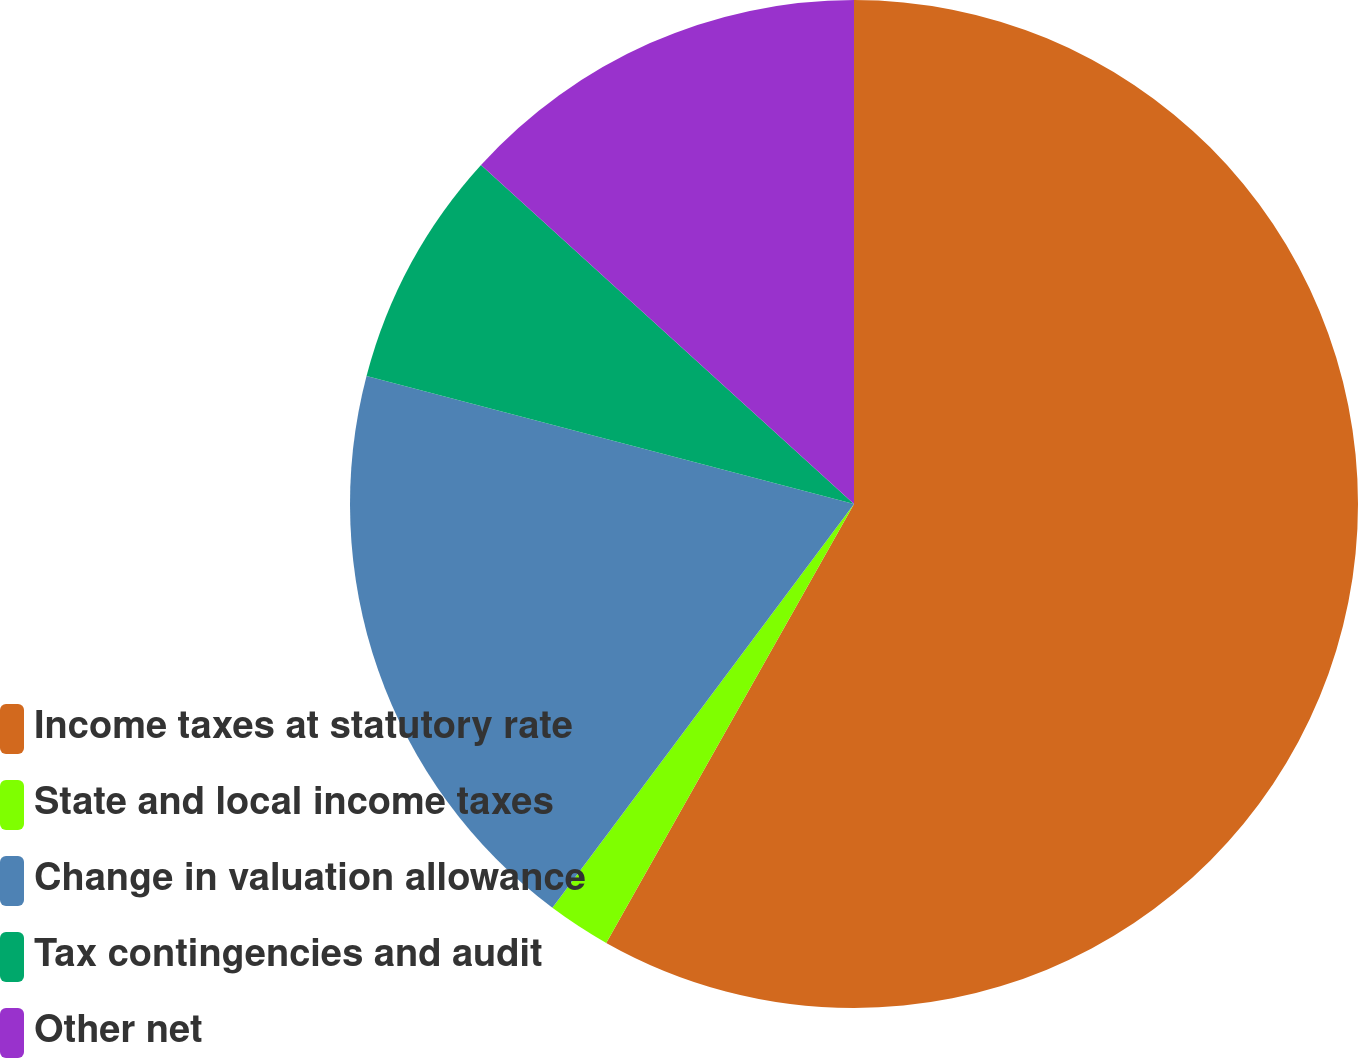<chart> <loc_0><loc_0><loc_500><loc_500><pie_chart><fcel>Income taxes at statutory rate<fcel>State and local income taxes<fcel>Change in valuation allowance<fcel>Tax contingencies and audit<fcel>Other net<nl><fcel>58.18%<fcel>2.03%<fcel>18.88%<fcel>7.65%<fcel>13.26%<nl></chart> 